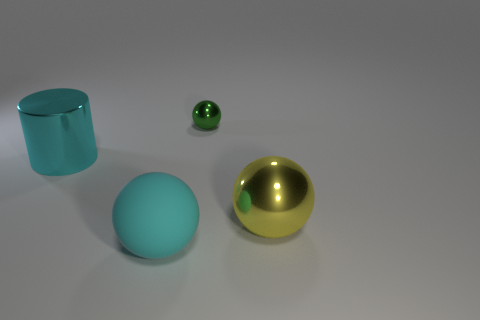There is a thing that is the same color as the large metallic cylinder; what size is it?
Provide a short and direct response. Large. There is a large cyan object in front of the large cyan cylinder; does it have the same shape as the large metal object that is on the right side of the cyan cylinder?
Provide a succinct answer. Yes. How many objects are either rubber spheres or large metallic cylinders?
Offer a terse response. 2. What is the size of the yellow metal object that is the same shape as the large matte object?
Offer a terse response. Large. How big is the green sphere?
Offer a very short reply. Small. Is the number of large spheres that are in front of the large yellow thing greater than the number of purple balls?
Offer a terse response. Yes. Are there any other things that are made of the same material as the cyan sphere?
Your answer should be compact. No. There is a object on the left side of the matte object; is it the same color as the ball that is to the left of the small ball?
Keep it short and to the point. Yes. There is a cyan thing in front of the metal ball that is in front of the cyan thing that is left of the large cyan rubber sphere; what is its material?
Keep it short and to the point. Rubber. Is the number of cyan rubber balls greater than the number of shiny balls?
Make the answer very short. No. 